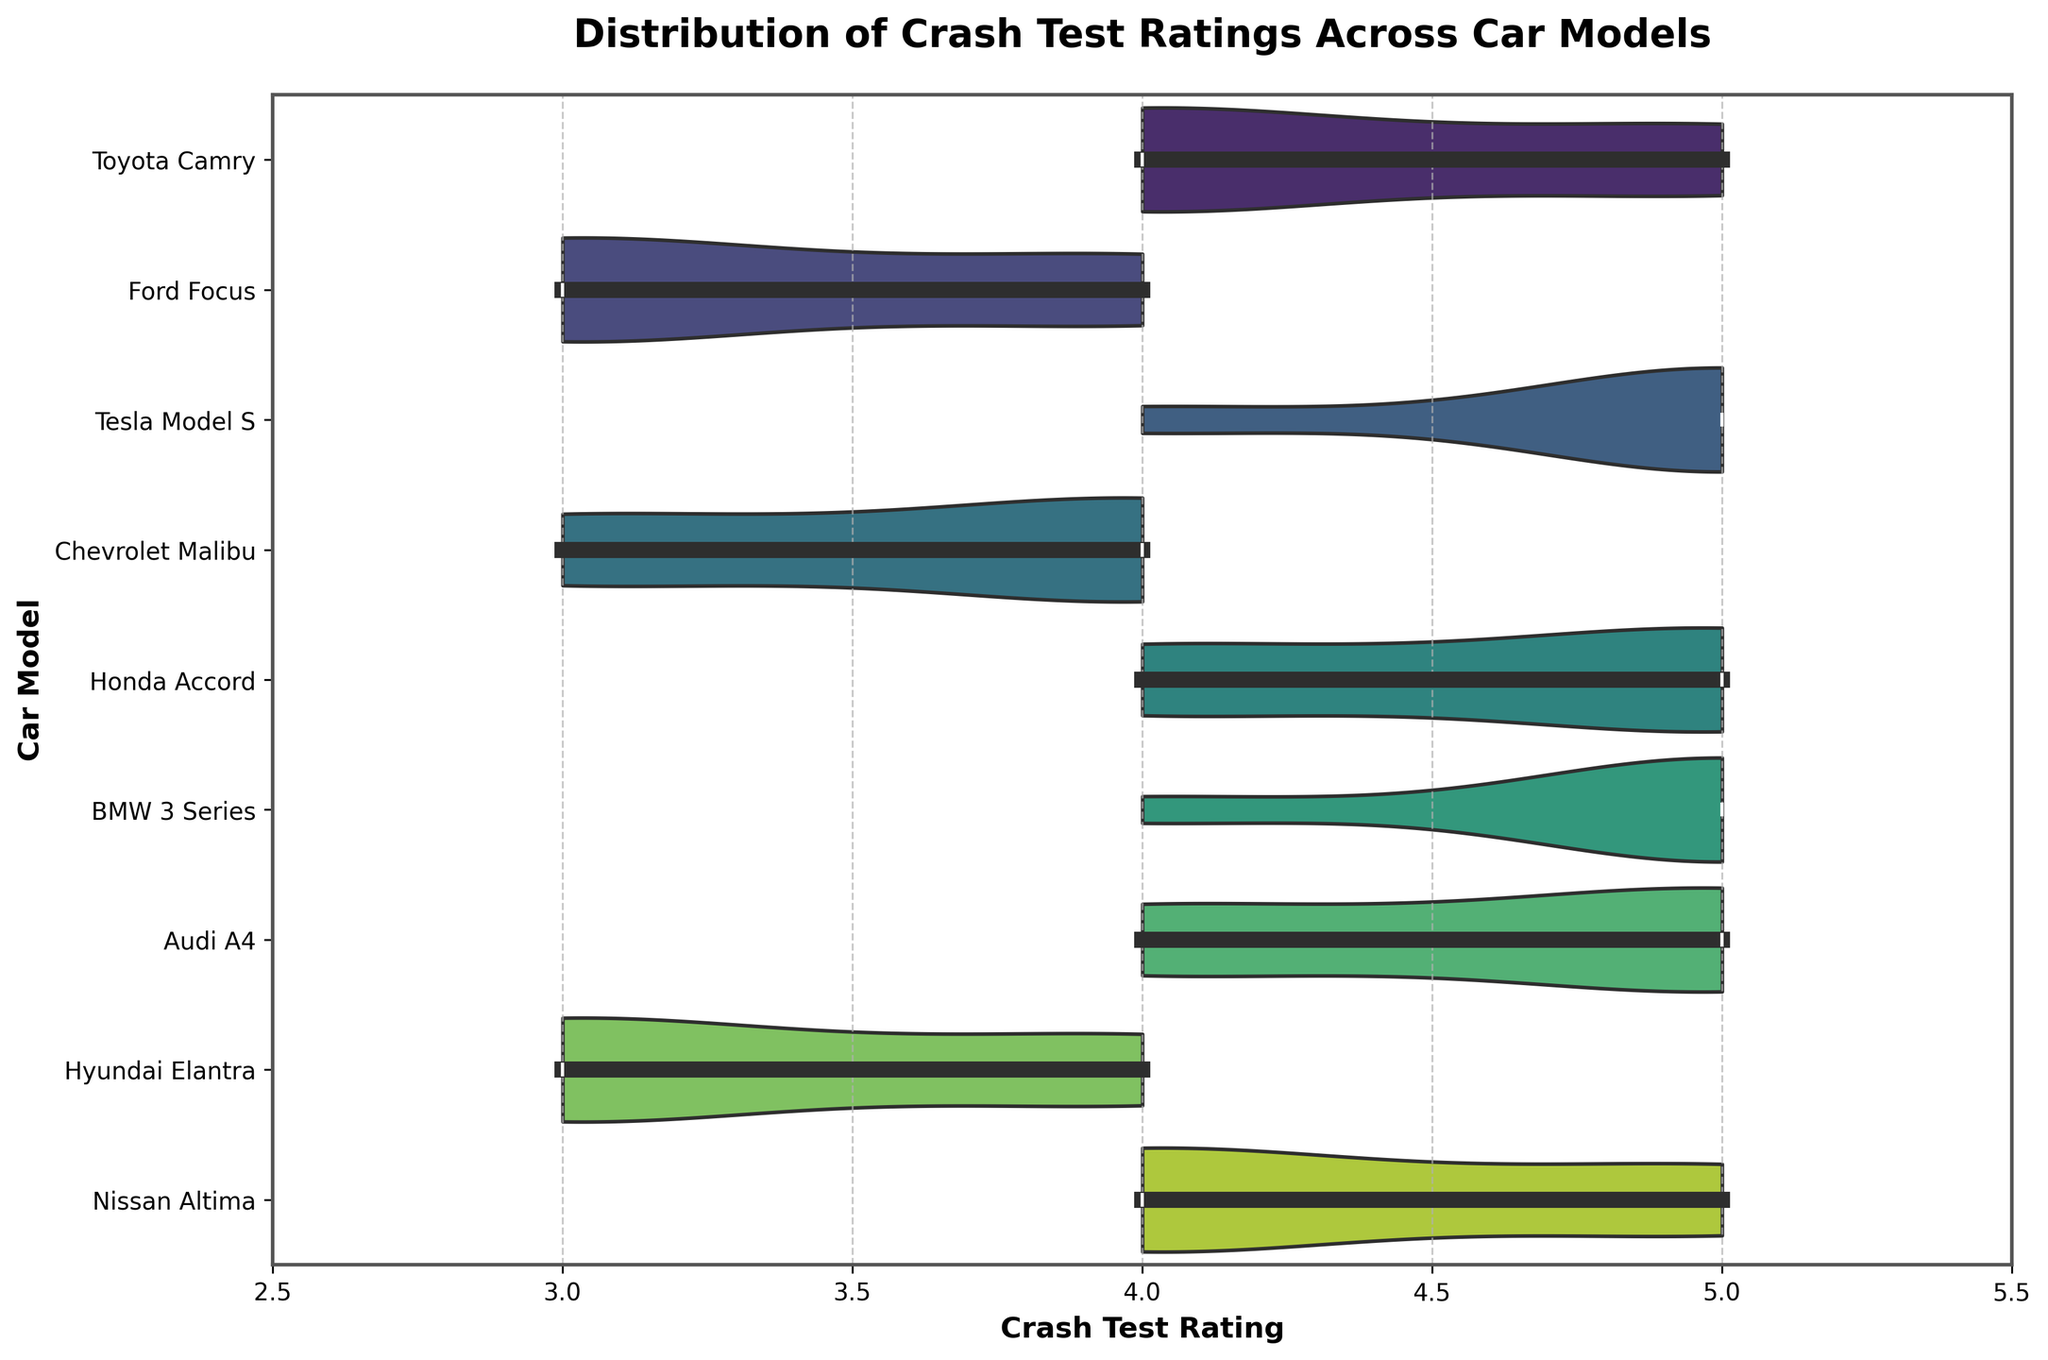What's the title of the figure? The title of a figure is usually located at the top, providing a brief description of the data being visualized. In this case, the title reads "Distribution of Crash Test Ratings Across Car Models."
Answer: Distribution of Crash Test Ratings Across Car Models How many different car models are displayed in the figure? Each car model has its own unique horizontal violin plot. By counting these plots, we can determine there are nine car models in total displayed in the figure.
Answer: Nine Which car model shows the widest distribution of crash test ratings? We need to identify the car model with the widest spread in its violin plot. The Ford Focus has a wide spread from ratings 3 to 4, indicating the widest distribution.
Answer: Ford Focus What is the most frequent crash test rating for the Toyota Camry? By examining the density of the violin plot for the Toyota Camry, we see that the rating of 4 has the highest density, indicating it is the most frequent.
Answer: 4 Which car models have crash test ratings that only include 4 and 5? Looking for car models where the violin plot does not extend beyond the ratings 4 and 5, we identify Toyota Camry, Tesla Model S, Honda Accord, BMW 3 Series, Audi A4, and Nissan Altima.
Answer: Toyota Camry, Tesla Model S, Honda Accord, BMW 3 Series, Audi A4, Nissan Altima Do any car models have a consistent crash test rating of 5? Since the violin plots for all car models show some distribution, none have a consistent rating of 5.
Answer: No What is the median crash test rating for the Hyundai Elantra? The median is represented by the thick horizontal line inside each violin plot. For the Hyundai Elantra, this median line aligns with the rating of 3.
Answer: 3 How does the distribution of crash test ratings for the Chevrolet Malibu compare to that of the Hyundai Elantra? Comparing the violin plots, both Chevrolet Malibu and Hyundai Elantra have ratings from 3 to 4. However, Hyundai Elantra's plot is more concentrated around the rating of 3, while Chevrolet Malibu's plot shows a more even distribution between 3 and 4.
Answer: Both range from 3 to 4, but Malibu is more evenly distributed Which car model has the highest proportion of 5 ratings? We need to find the violin plot with the largest area at rating 5. Both the Tesla Model S and BMW 3 Series have significant areas at rating 5, suggesting a high proportion.
Answer: Tesla Model S, BMW 3 Series 